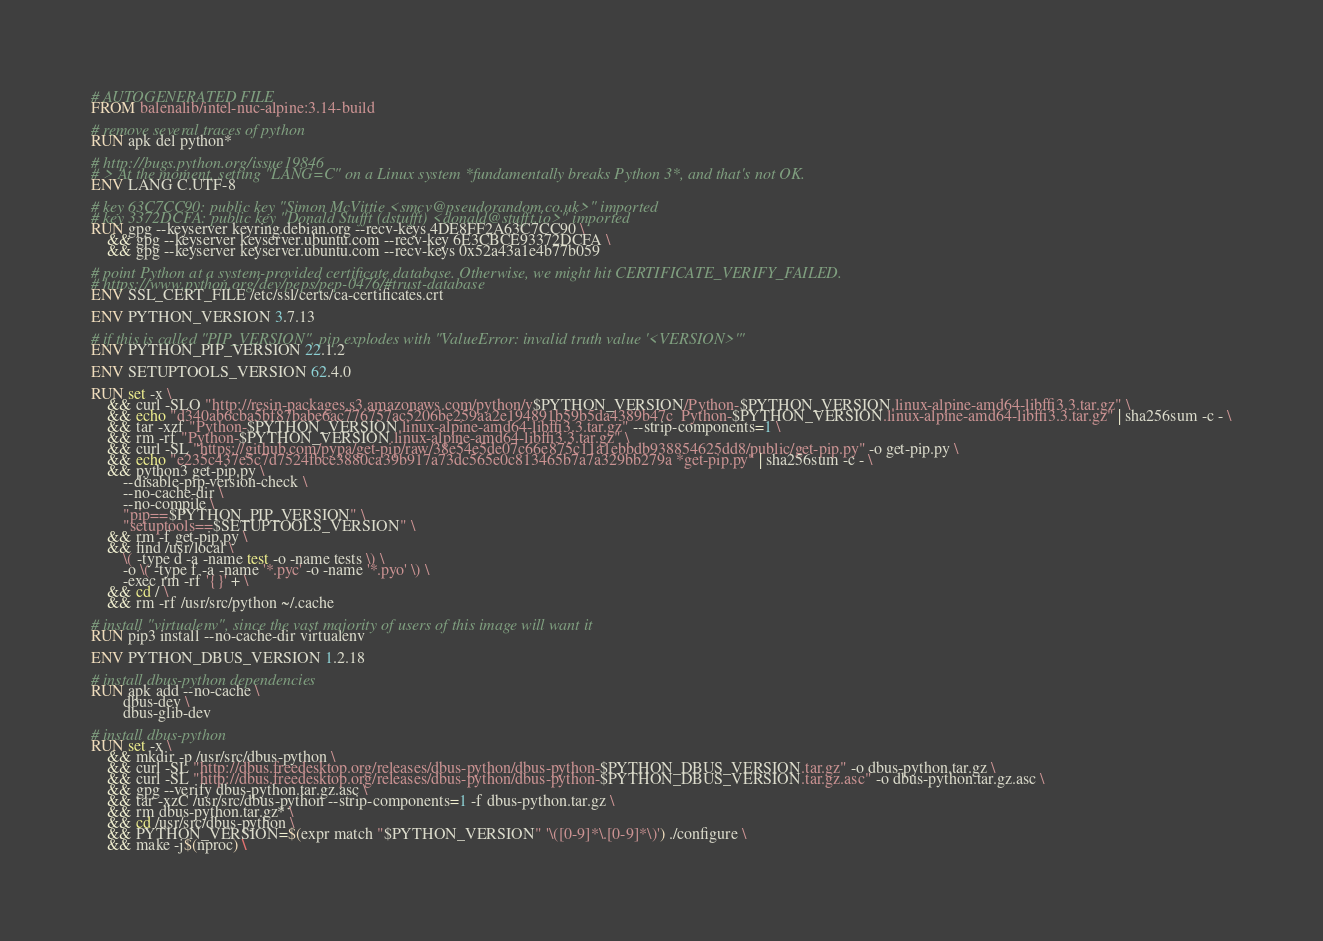Convert code to text. <code><loc_0><loc_0><loc_500><loc_500><_Dockerfile_># AUTOGENERATED FILE
FROM balenalib/intel-nuc-alpine:3.14-build

# remove several traces of python
RUN apk del python*

# http://bugs.python.org/issue19846
# > At the moment, setting "LANG=C" on a Linux system *fundamentally breaks Python 3*, and that's not OK.
ENV LANG C.UTF-8

# key 63C7CC90: public key "Simon McVittie <smcv@pseudorandom.co.uk>" imported
# key 3372DCFA: public key "Donald Stufft (dstufft) <donald@stufft.io>" imported
RUN gpg --keyserver keyring.debian.org --recv-keys 4DE8FF2A63C7CC90 \
	&& gpg --keyserver keyserver.ubuntu.com --recv-key 6E3CBCE93372DCFA \
	&& gpg --keyserver keyserver.ubuntu.com --recv-keys 0x52a43a1e4b77b059

# point Python at a system-provided certificate database. Otherwise, we might hit CERTIFICATE_VERIFY_FAILED.
# https://www.python.org/dev/peps/pep-0476/#trust-database
ENV SSL_CERT_FILE /etc/ssl/certs/ca-certificates.crt

ENV PYTHON_VERSION 3.7.13

# if this is called "PIP_VERSION", pip explodes with "ValueError: invalid truth value '<VERSION>'"
ENV PYTHON_PIP_VERSION 22.1.2

ENV SETUPTOOLS_VERSION 62.4.0

RUN set -x \
	&& curl -SLO "http://resin-packages.s3.amazonaws.com/python/v$PYTHON_VERSION/Python-$PYTHON_VERSION.linux-alpine-amd64-libffi3.3.tar.gz" \
	&& echo "d340ab6cba5bf87babe6ac776757ac5206be259aa2e194891b59b5da4389b47c  Python-$PYTHON_VERSION.linux-alpine-amd64-libffi3.3.tar.gz" | sha256sum -c - \
	&& tar -xzf "Python-$PYTHON_VERSION.linux-alpine-amd64-libffi3.3.tar.gz" --strip-components=1 \
	&& rm -rf "Python-$PYTHON_VERSION.linux-alpine-amd64-libffi3.3.tar.gz" \
	&& curl -SL "https://github.com/pypa/get-pip/raw/38e54e5de07c66e875c11a1ebbdb938854625dd8/public/get-pip.py" -o get-pip.py \
    && echo "e235c437e5c7d7524fbce3880ca39b917a73dc565e0c813465b7a7a329bb279a *get-pip.py" | sha256sum -c - \
    && python3 get-pip.py \
        --disable-pip-version-check \
        --no-cache-dir \
        --no-compile \
        "pip==$PYTHON_PIP_VERSION" \
        "setuptools==$SETUPTOOLS_VERSION" \
	&& rm -f get-pip.py \
	&& find /usr/local \
		\( -type d -a -name test -o -name tests \) \
		-o \( -type f -a -name '*.pyc' -o -name '*.pyo' \) \
		-exec rm -rf '{}' + \
	&& cd / \
	&& rm -rf /usr/src/python ~/.cache

# install "virtualenv", since the vast majority of users of this image will want it
RUN pip3 install --no-cache-dir virtualenv

ENV PYTHON_DBUS_VERSION 1.2.18

# install dbus-python dependencies 
RUN apk add --no-cache \
		dbus-dev \
		dbus-glib-dev

# install dbus-python
RUN set -x \
	&& mkdir -p /usr/src/dbus-python \
	&& curl -SL "http://dbus.freedesktop.org/releases/dbus-python/dbus-python-$PYTHON_DBUS_VERSION.tar.gz" -o dbus-python.tar.gz \
	&& curl -SL "http://dbus.freedesktop.org/releases/dbus-python/dbus-python-$PYTHON_DBUS_VERSION.tar.gz.asc" -o dbus-python.tar.gz.asc \
	&& gpg --verify dbus-python.tar.gz.asc \
	&& tar -xzC /usr/src/dbus-python --strip-components=1 -f dbus-python.tar.gz \
	&& rm dbus-python.tar.gz* \
	&& cd /usr/src/dbus-python \
	&& PYTHON_VERSION=$(expr match "$PYTHON_VERSION" '\([0-9]*\.[0-9]*\)') ./configure \
	&& make -j$(nproc) \</code> 